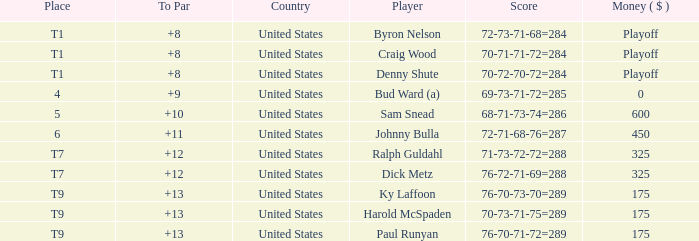What was the country for Sam Snead? United States. 